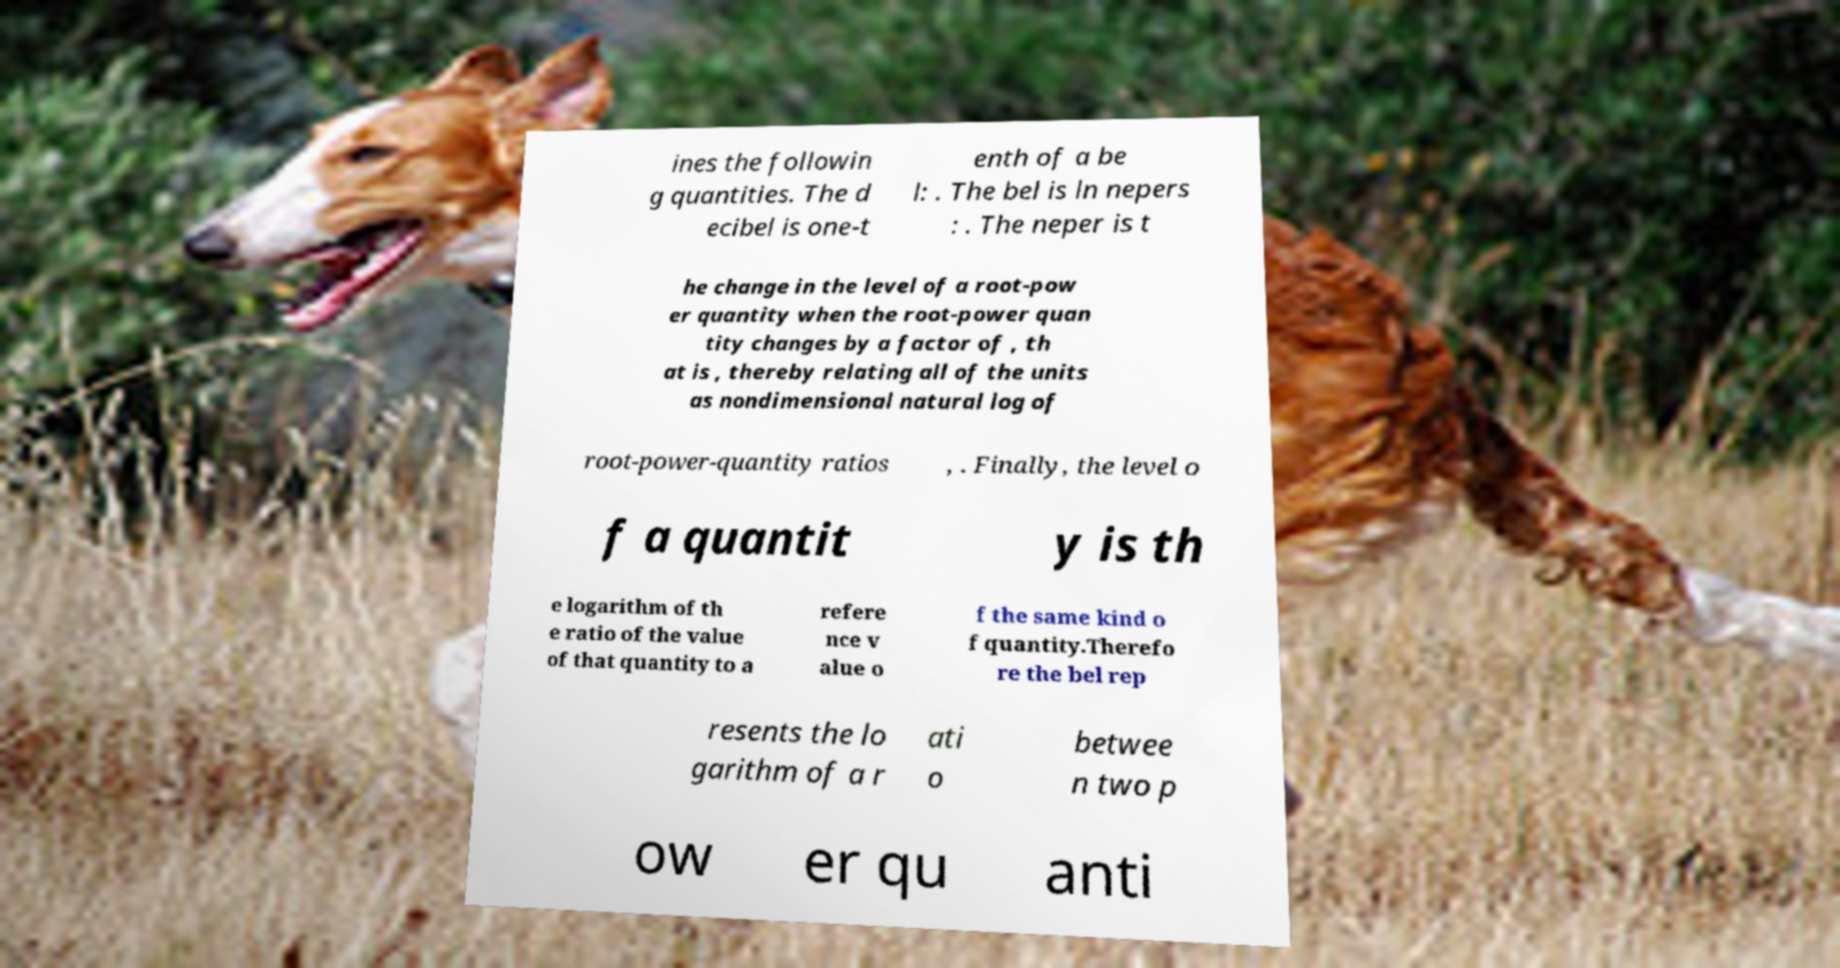Could you assist in decoding the text presented in this image and type it out clearly? ines the followin g quantities. The d ecibel is one-t enth of a be l: . The bel is ln nepers : . The neper is t he change in the level of a root-pow er quantity when the root-power quan tity changes by a factor of , th at is , thereby relating all of the units as nondimensional natural log of root-power-quantity ratios , . Finally, the level o f a quantit y is th e logarithm of th e ratio of the value of that quantity to a refere nce v alue o f the same kind o f quantity.Therefo re the bel rep resents the lo garithm of a r ati o betwee n two p ow er qu anti 